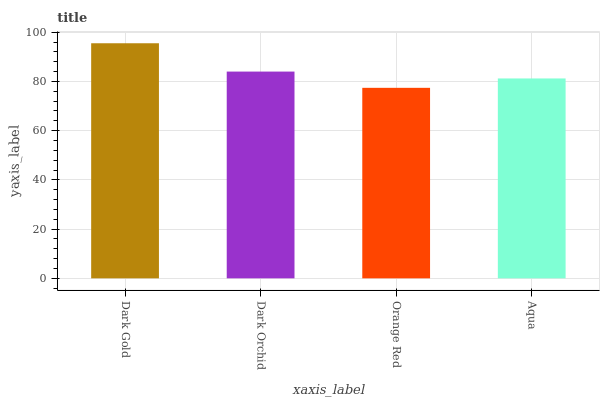Is Orange Red the minimum?
Answer yes or no. Yes. Is Dark Gold the maximum?
Answer yes or no. Yes. Is Dark Orchid the minimum?
Answer yes or no. No. Is Dark Orchid the maximum?
Answer yes or no. No. Is Dark Gold greater than Dark Orchid?
Answer yes or no. Yes. Is Dark Orchid less than Dark Gold?
Answer yes or no. Yes. Is Dark Orchid greater than Dark Gold?
Answer yes or no. No. Is Dark Gold less than Dark Orchid?
Answer yes or no. No. Is Dark Orchid the high median?
Answer yes or no. Yes. Is Aqua the low median?
Answer yes or no. Yes. Is Dark Gold the high median?
Answer yes or no. No. Is Orange Red the low median?
Answer yes or no. No. 